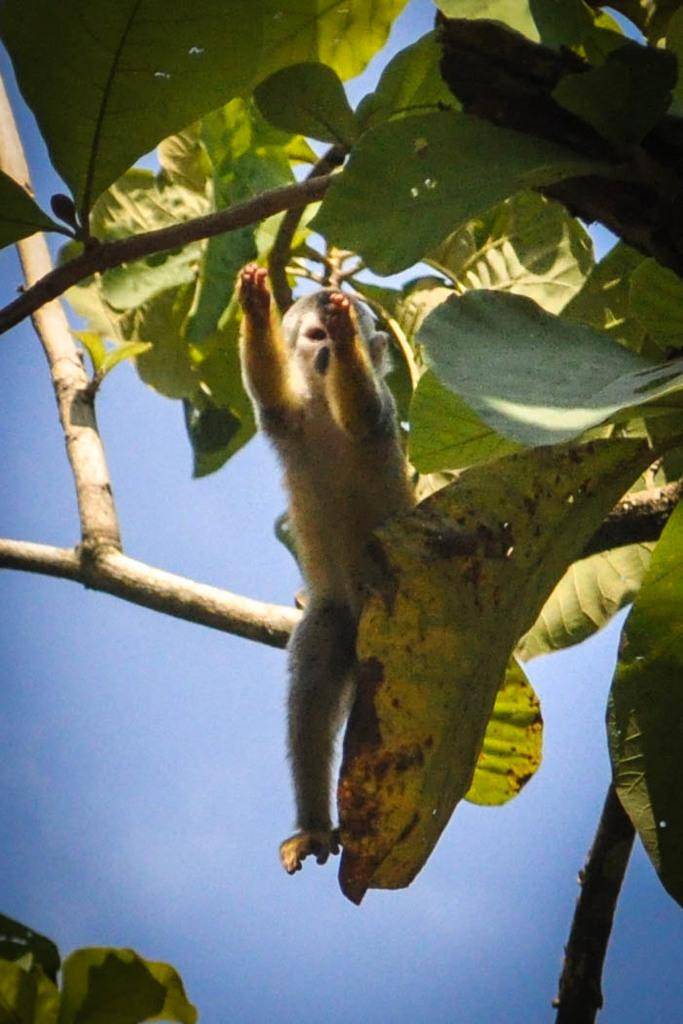What animal is present in the image? There is a monkey in the image. Where is the monkey located? The monkey is on a tree. What can be seen in the background of the image? The sky is visible in the background of the image. Are there any fairies flying around the monkey in the image? There are no fairies present in the image; it only features a monkey on a tree with a visible sky in the background. 